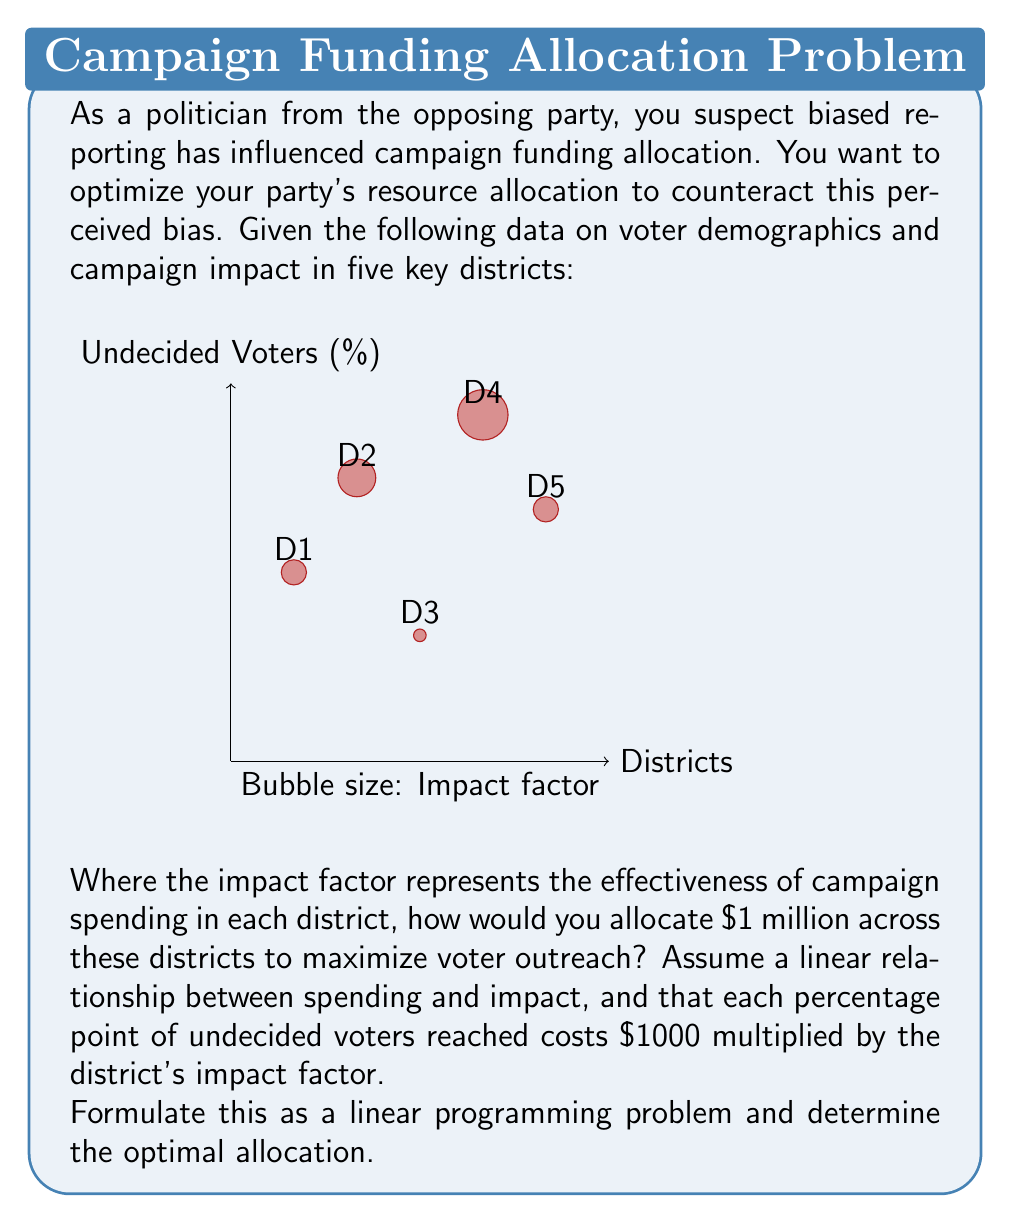Provide a solution to this math problem. Let's approach this step-by-step:

1) Define variables:
   Let $x_i$ be the amount spent in district $i$ (in thousands of dollars), where $i = 1,2,3,4,5$.

2) Objective function:
   We want to maximize the total number of undecided voters reached. This is given by:
   $$\text{Maximize } Z = \sum_{i=1}^5 \frac{y_i x_i}{1000f_i}$$
   where $y_i$ is the percentage of undecided voters and $f_i$ is the impact factor for district $i$.

3) Constraints:
   - Total budget constraint: $\sum_{i=1}^5 x_i \leq 1000$ (as we have $1 million to allocate)
   - Non-negativity: $x_i \geq 0$ for all $i$

4) Substituting the given values:
   $$\text{Maximize } Z = \frac{30x_1}{2000} + \frac{45x_2}{3000} + \frac{20x_3}{1000} + \frac{55x_4}{4000} + \frac{40x_5}{2000}$$
   $$\text{Subject to: } x_1 + x_2 + x_3 + x_4 + x_5 \leq 1000$$
   $$x_1, x_2, x_3, x_4, x_5 \geq 0$$

5) This is a standard linear programming problem. We can solve it using the simplex method or linear programming software. The optimal solution is:

   $x_1 = 0, x_2 = 0, x_3 = 1000, x_4 = 0, x_5 = 0$

6) Interpretation: The optimal strategy is to allocate all $1 million to District 3, which has the highest ratio of undecided voters to impact factor.
Answer: Allocate entire $1 million to District 3. 